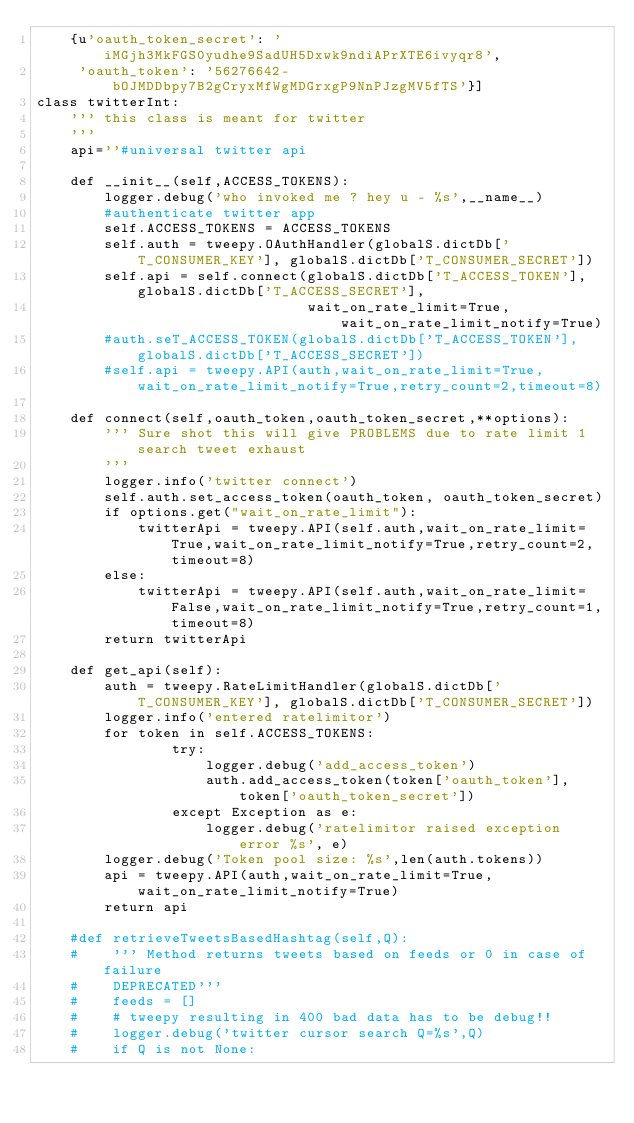<code> <loc_0><loc_0><loc_500><loc_500><_Python_>    {u'oauth_token_secret': 'iMGjh3MkFGS0yudhe9SadUH5Dxwk9ndiAPrXTE6ivyqr8',
     'oauth_token': '56276642-bOJMDDbpy7B2gCryxMfWgMDGrxgP9NnPJzgMV5fTS'}]
class twitterInt:
    ''' this class is meant for twitter
    '''
    api=''#universal twitter api

    def __init__(self,ACCESS_TOKENS):
        logger.debug('who invoked me ? hey u - %s',__name__)
        #authenticate twitter app
        self.ACCESS_TOKENS = ACCESS_TOKENS
        self.auth = tweepy.OAuthHandler(globalS.dictDb['T_CONSUMER_KEY'], globalS.dictDb['T_CONSUMER_SECRET'])
        self.api = self.connect(globalS.dictDb['T_ACCESS_TOKEN'], globalS.dictDb['T_ACCESS_SECRET'],
                                wait_on_rate_limit=True,wait_on_rate_limit_notify=True)
        #auth.seT_ACCESS_TOKEN(globalS.dictDb['T_ACCESS_TOKEN'], globalS.dictDb['T_ACCESS_SECRET'])
        #self.api = tweepy.API(auth,wait_on_rate_limit=True,wait_on_rate_limit_notify=True,retry_count=2,timeout=8)

    def connect(self,oauth_token,oauth_token_secret,**options):
        ''' Sure shot this will give PROBLEMS due to rate limit 1 search tweet exhaust
        '''
        logger.info('twitter connect')
        self.auth.set_access_token(oauth_token, oauth_token_secret)
        if options.get("wait_on_rate_limit"):
            twitterApi = tweepy.API(self.auth,wait_on_rate_limit=True,wait_on_rate_limit_notify=True,retry_count=2,timeout=8)
        else:
            twitterApi = tweepy.API(self.auth,wait_on_rate_limit=False,wait_on_rate_limit_notify=True,retry_count=1,timeout=8)
        return twitterApi

    def get_api(self):
        auth = tweepy.RateLimitHandler(globalS.dictDb['T_CONSUMER_KEY'], globalS.dictDb['T_CONSUMER_SECRET'])
        logger.info('entered ratelimitor')
        for token in self.ACCESS_TOKENS:
                try:
                    logger.debug('add_access_token')
                    auth.add_access_token(token['oauth_token'],token['oauth_token_secret'])
                except Exception as e:
                    logger.debug('ratelimitor raised exception error %s', e)
        logger.debug('Token pool size: %s',len(auth.tokens))
        api = tweepy.API(auth,wait_on_rate_limit=True, wait_on_rate_limit_notify=True)
        return api

    #def retrieveTweetsBasedHashtag(self,Q):
    #    ''' Method returns tweets based on feeds or 0 in case of failure
    #    DEPRECATED'''
    #    feeds = []
    #    # tweepy resulting in 400 bad data has to be debug!!
    #    logger.debug('twitter cursor search Q=%s',Q)
    #    if Q is not None:</code> 